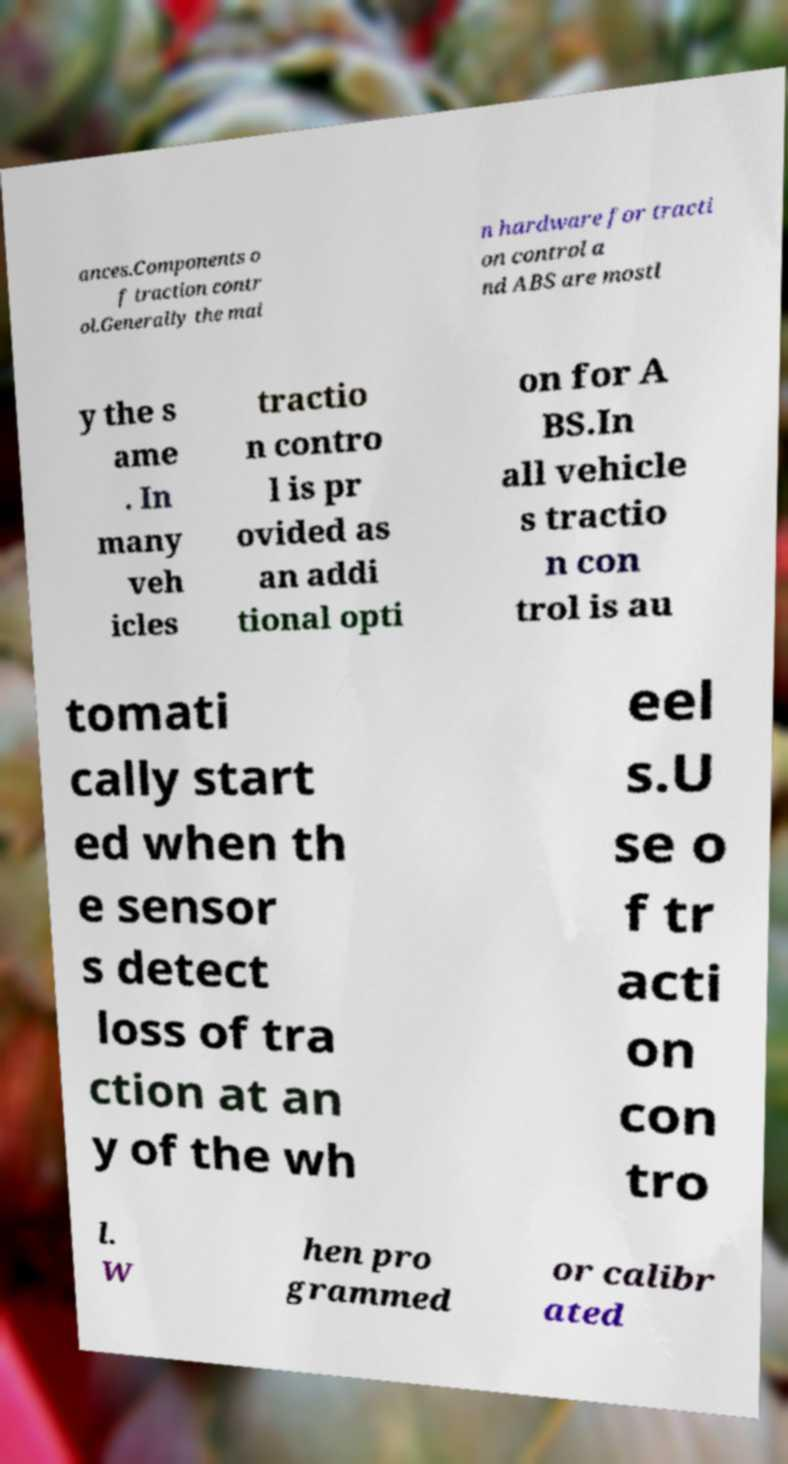For documentation purposes, I need the text within this image transcribed. Could you provide that? ances.Components o f traction contr ol.Generally the mai n hardware for tracti on control a nd ABS are mostl y the s ame . In many veh icles tractio n contro l is pr ovided as an addi tional opti on for A BS.In all vehicle s tractio n con trol is au tomati cally start ed when th e sensor s detect loss of tra ction at an y of the wh eel s.U se o f tr acti on con tro l. W hen pro grammed or calibr ated 